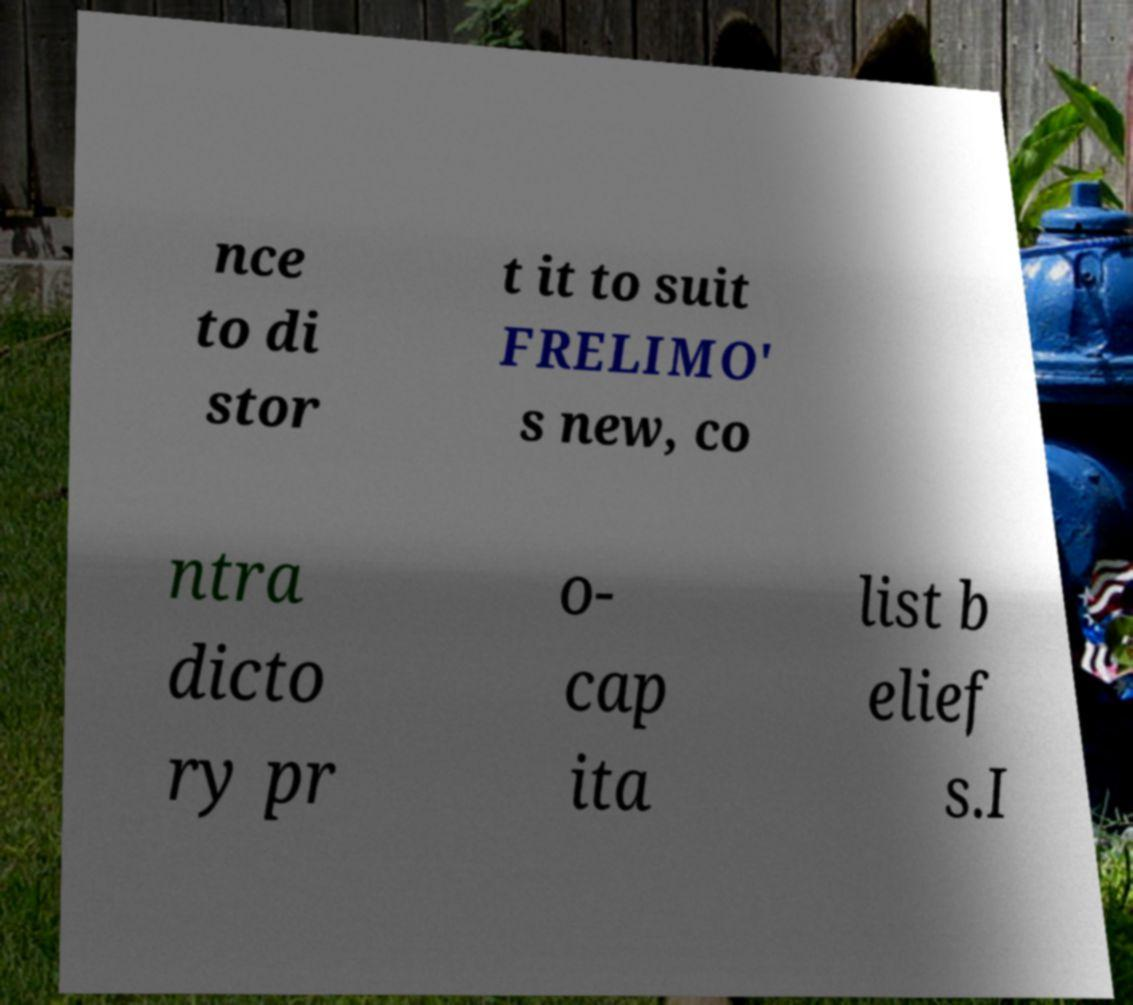What messages or text are displayed in this image? I need them in a readable, typed format. nce to di stor t it to suit FRELIMO' s new, co ntra dicto ry pr o- cap ita list b elief s.I 